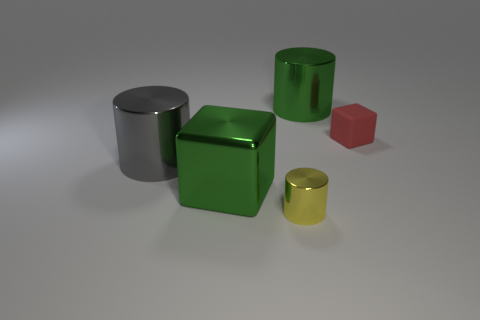Subtract 1 cylinders. How many cylinders are left? 2 Add 3 small green matte cubes. How many objects exist? 8 Subtract all blocks. How many objects are left? 3 Subtract all green matte cylinders. Subtract all large gray shiny cylinders. How many objects are left? 4 Add 2 small shiny cylinders. How many small shiny cylinders are left? 3 Add 1 red objects. How many red objects exist? 2 Subtract 0 cyan cylinders. How many objects are left? 5 